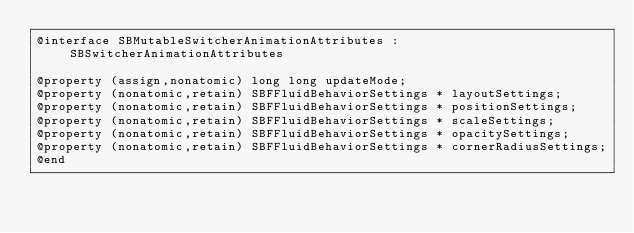Convert code to text. <code><loc_0><loc_0><loc_500><loc_500><_C_>@interface SBMutableSwitcherAnimationAttributes : SBSwitcherAnimationAttributes

@property (assign,nonatomic) long long updateMode; 
@property (nonatomic,retain) SBFFluidBehaviorSettings * layoutSettings; 
@property (nonatomic,retain) SBFFluidBehaviorSettings * positionSettings; 
@property (nonatomic,retain) SBFFluidBehaviorSettings * scaleSettings; 
@property (nonatomic,retain) SBFFluidBehaviorSettings * opacitySettings; 
@property (nonatomic,retain) SBFFluidBehaviorSettings * cornerRadiusSettings; 
@end

</code> 